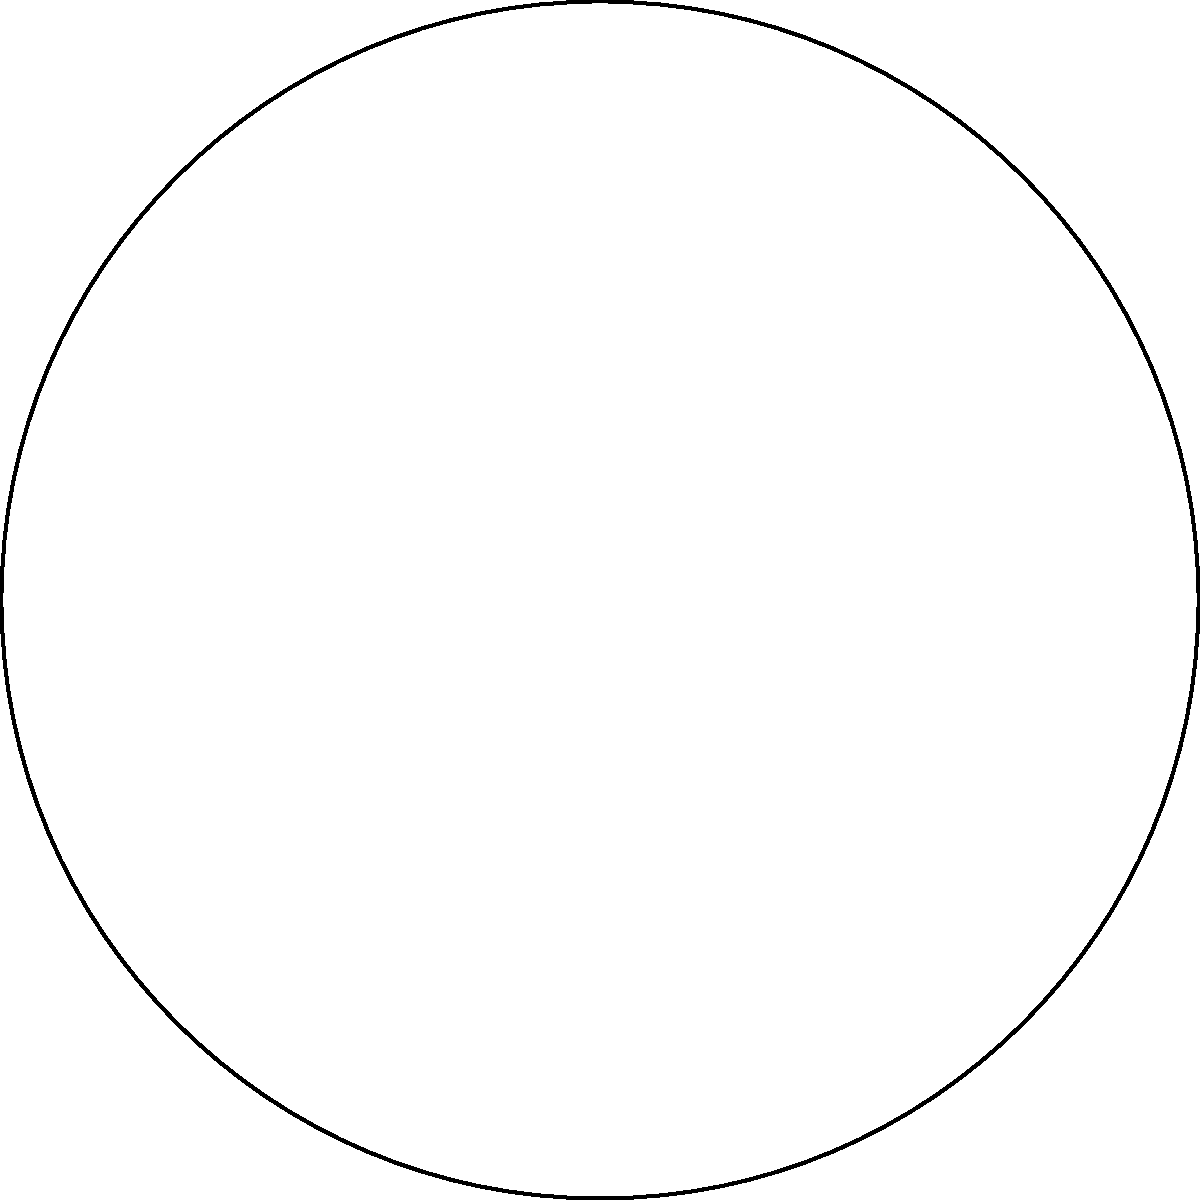In a dense forest within the indigenous community's land, two branching paths are represented by blue and red lines on a hyperbolic plane model. If these paths continue indefinitely, what will happen to the distance between them? To understand this scenario, we need to consider the properties of parallel lines in hyperbolic geometry:

1. In Euclidean geometry, parallel lines maintain a constant distance. However, hyperbolic geometry behaves differently.

2. The blue and red lines represent geodesics (shortest paths) on the hyperbolic plane, analogous to straight lines in Euclidean geometry.

3. In hyperbolic geometry, given a line and a point not on that line, there are infinitely many lines through the point that do not intersect the original line. This is known as the hyperbolic parallel postulate.

4. The Poincaré disk model is used here to visualize the hyperbolic plane, where the circular boundary represents infinity.

5. In this model, geodesics are represented by either diameters of the disk or circular arcs that intersect the boundary perpendicularly.

6. The blue and red paths start at different points (A and B) and extend towards different points on the boundary (P and Q).

7. As these paths approach the boundary of the disk (representing infinity in the hyperbolic plane), they diverge from each other.

8. In hyperbolic geometry, the distance between these parallel paths will increase exponentially as they extend towards infinity.

Therefore, unlike in Euclidean geometry where parallel lines maintain a constant distance, in this hyperbolic representation of the forest, the distance between the two branching paths will continually increase as they extend further.
Answer: The distance between the paths will increase indefinitely. 